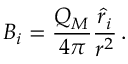Convert formula to latex. <formula><loc_0><loc_0><loc_500><loc_500>B _ { i } = { \frac { Q _ { M } } { 4 \pi } } { \frac { { \hat { r } } _ { i } } { r ^ { 2 } } } \, .</formula> 